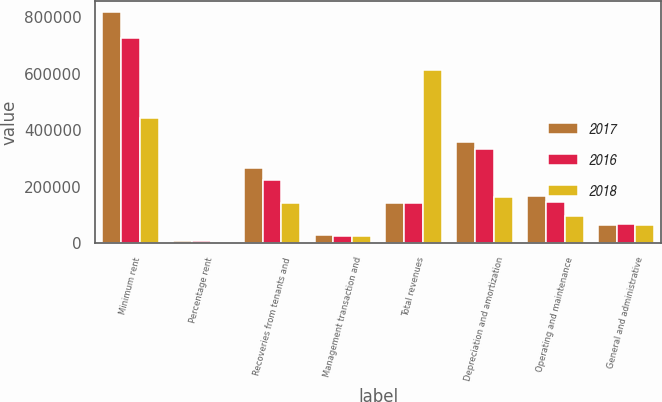Convert chart. <chart><loc_0><loc_0><loc_500><loc_500><stacked_bar_chart><ecel><fcel>Minimum rent<fcel>Percentage rent<fcel>Recoveries from tenants and<fcel>Management transaction and<fcel>Total revenues<fcel>Depreciation and amortization<fcel>Operating and maintenance<fcel>General and administrative<nl><fcel>2017<fcel>818483<fcel>7486<fcel>266512<fcel>28494<fcel>142300<fcel>359688<fcel>168034<fcel>65491<nl><fcel>2016<fcel>728078<fcel>6635<fcel>223455<fcel>26158<fcel>142300<fcel>334201<fcel>143990<fcel>67624<nl><fcel>2018<fcel>444305<fcel>4128<fcel>140611<fcel>25327<fcel>614371<fcel>162327<fcel>95022<fcel>65327<nl></chart> 